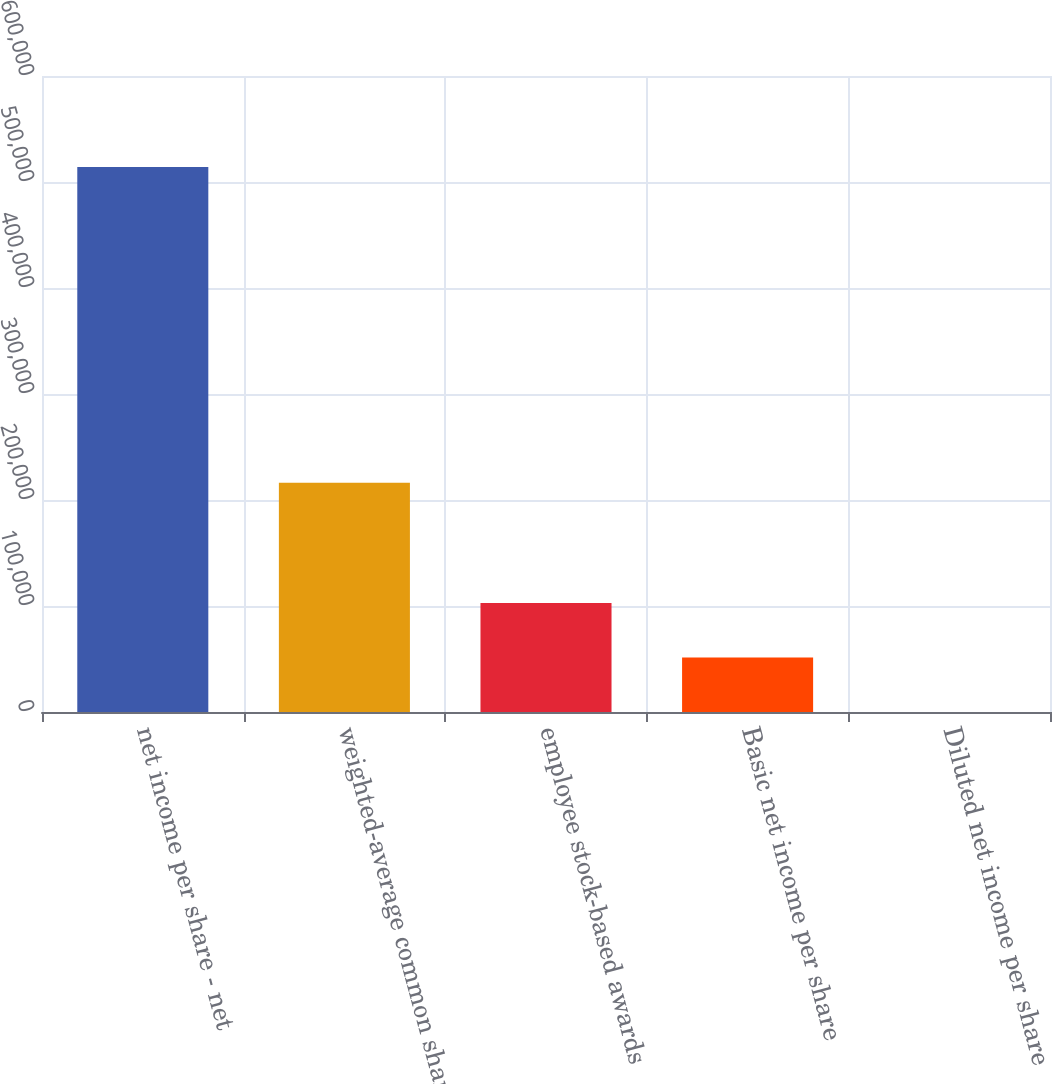Convert chart. <chart><loc_0><loc_0><loc_500><loc_500><bar_chart><fcel>net income per share - net<fcel>weighted-average common shares<fcel>employee stock-based awards<fcel>Basic net income per share<fcel>Diluted net income per share<nl><fcel>514123<fcel>216340<fcel>102826<fcel>51414.4<fcel>2.35<nl></chart> 